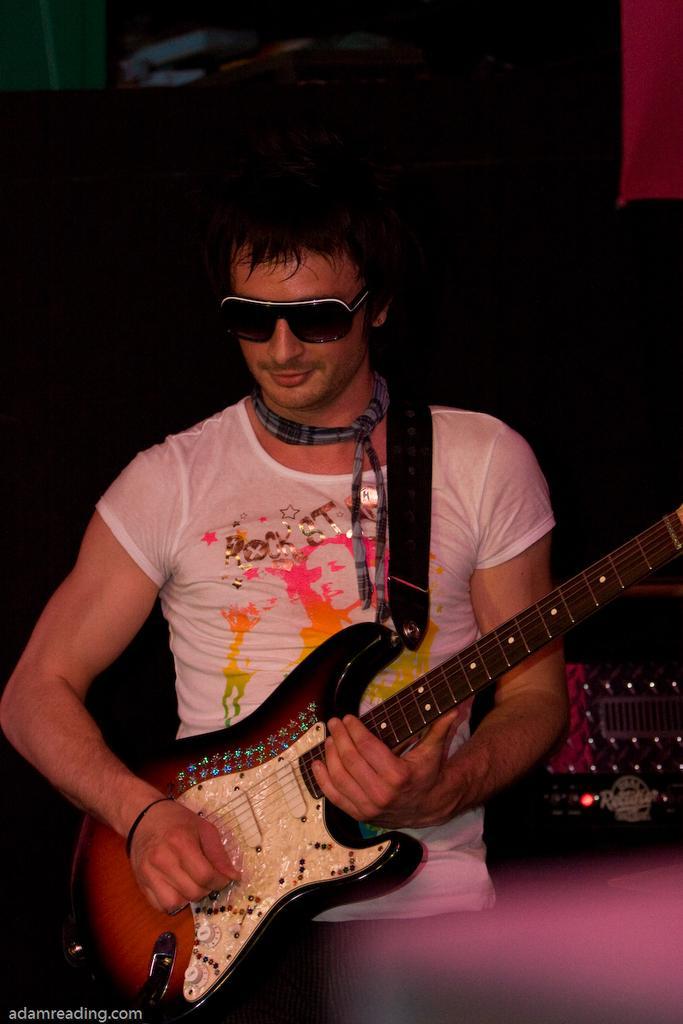How would you summarize this image in a sentence or two? In this image in the middle there is a man he wears white t shirt he is playing guitar. In the background there are lights. 